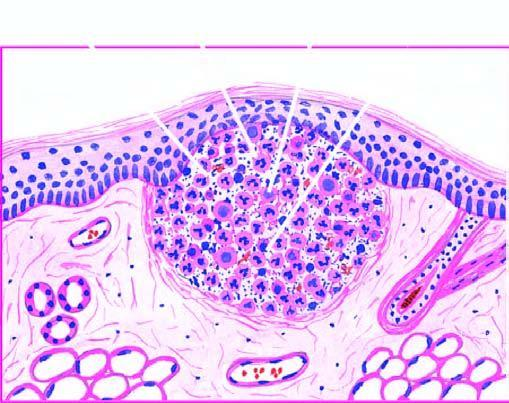re some macrophages seen at the periphery?
Answer the question using a single word or phrase. Yes 